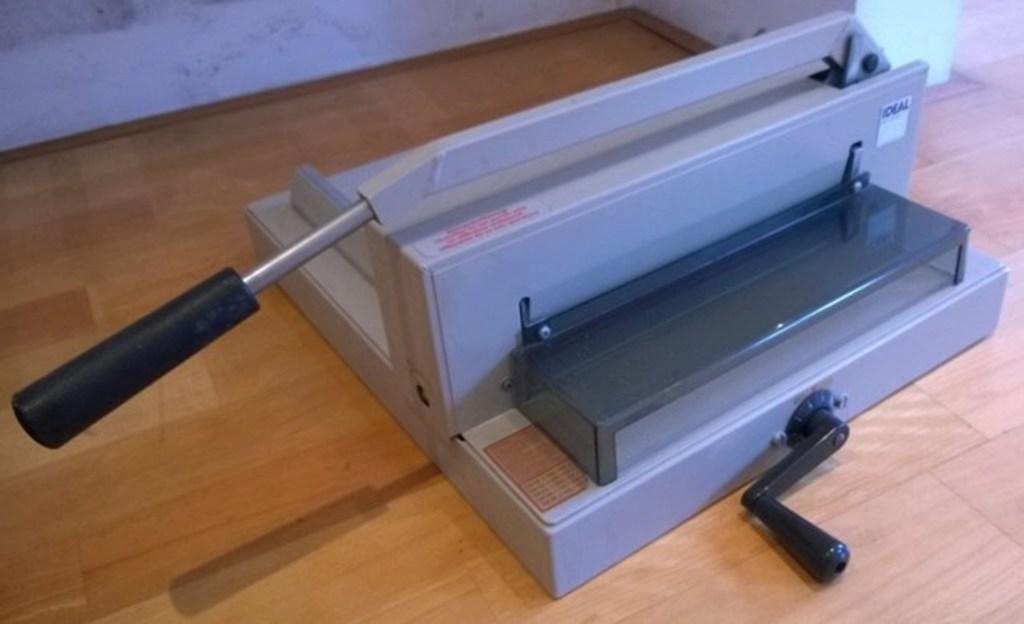What is the main object on the ground in the image? There is a binding machine on the ground. What is the background of the image? There is a wall in the image. What type of picture is hanging on the border in the image? There is no picture or border present in the image; it only features a binding machine on the ground and a wall in the background. 